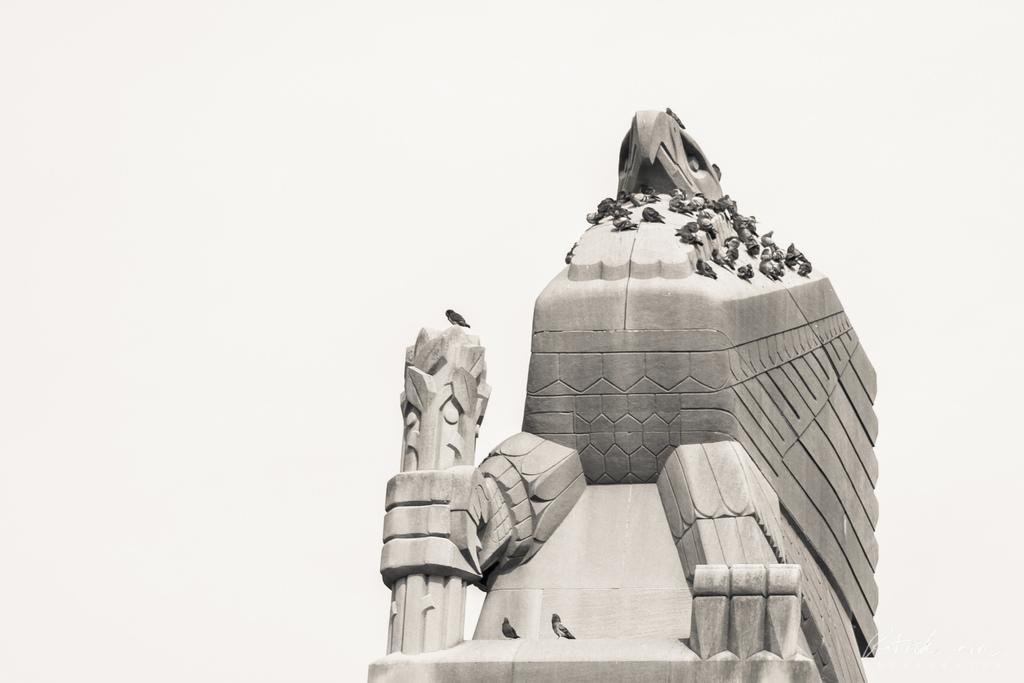How would you summarize this image in a sentence or two? In this image there are birds on a concrete structure. 